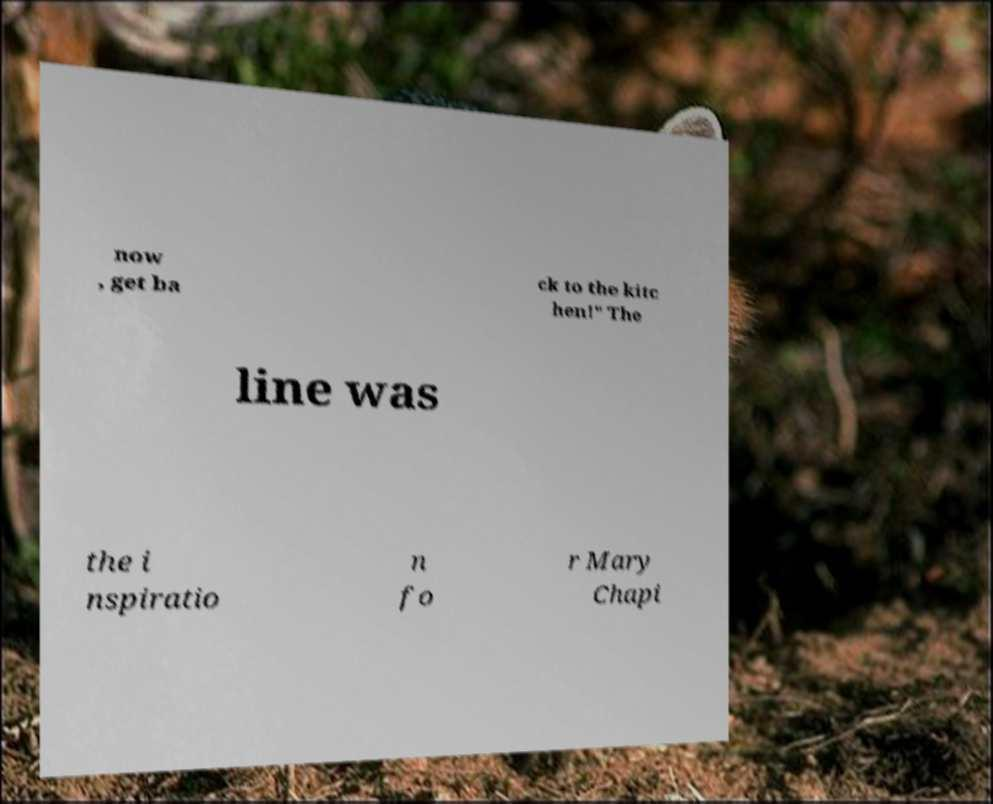Can you read and provide the text displayed in the image?This photo seems to have some interesting text. Can you extract and type it out for me? now , get ba ck to the kitc hen!" The line was the i nspiratio n fo r Mary Chapi 